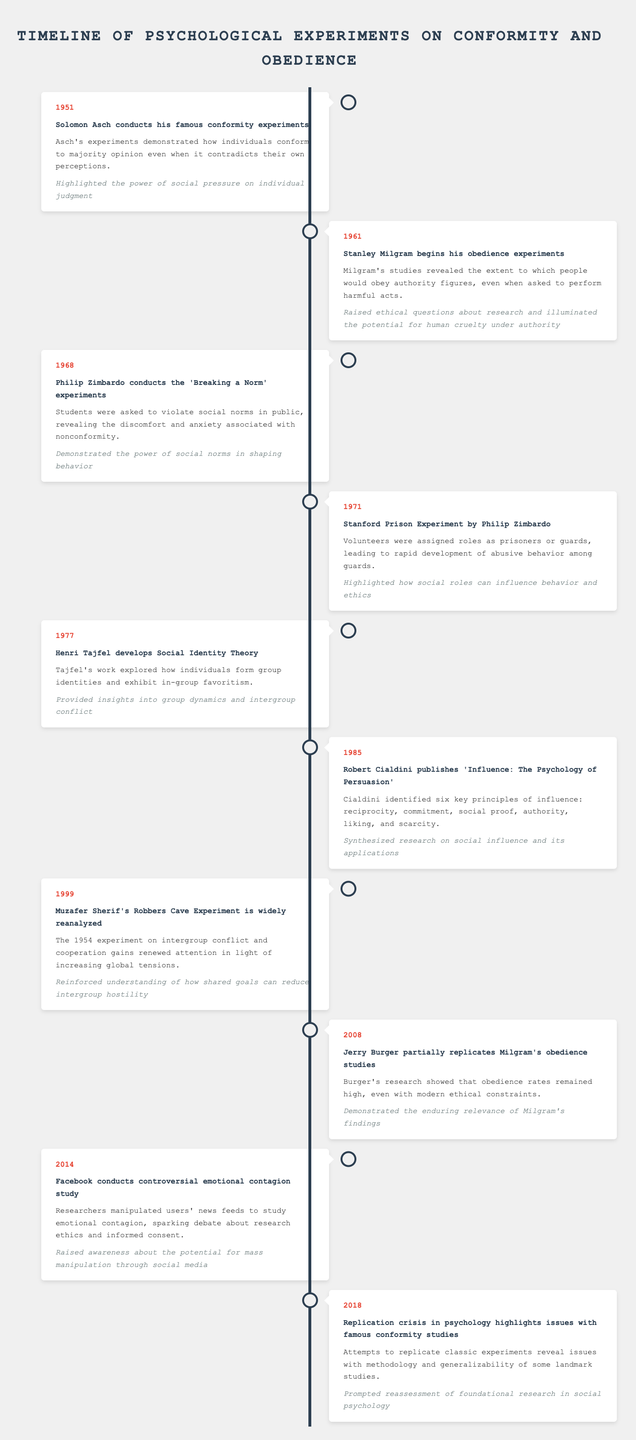What year did Solomon Asch conduct his famous conformity experiments? According to the table, Solomon Asch conducted his famous conformity experiments in the year 1951, as explicitly stated in the data provided.
Answer: 1951 What significant effect did Solomon Asch's experiments highlight? The table states that Asch's experiments highlighted the power of social pressure on individual judgment, which illustrates the impact of group dynamics on personal beliefs.
Answer: Social pressure on individual judgment Which experiment revealed the extent to which people would obey authority figures? The table indicates that Stanley Milgram's obedience experiments, beginning in 1961, revealed this significant insight about obedience to authority, as outlined in the event description.
Answer: Stanley Milgram's obedience experiments How many years apart were Asch's and Milgram's studies conducted? Asch's experiments were conducted in 1951 and Milgram's in 1961. The difference between these years is 1961 - 1951 = 10 years, indicating they are a decade apart in timing.
Answer: 10 years Was the Stanford Prison Experiment conducted before or after the development of Social Identity Theory by Henri Tajfel? The Stanford Prison Experiment occurred in 1971, while Social Identity Theory was developed in 1977. Since 1971 is before 1977, the answer is that the Stanford Prison Experiment was conducted before the development of Social Identity Theory.
Answer: Before What is the main focus of Philip Zimbardo’s 'Breaking a Norm' experiments conducted in 1968? The 1968 experiments conducted by Zimbardo focused on having students violate social norms in public, revealing the discomfort and anxiety associated with nonconformity, according to the description in the table.
Answer: Violation of social norms What notable outcome did Jerry Burger's partial replication of Milgram’s obedience studies in 2008 demonstrate? The significance of Jerry Burger's 2008 replication, as stated in the data, shows that obedience rates remained high even under modern ethical constraints, suggesting that the findings of Milgram’s original study are still relevant today.
Answer: Obedience rates remained high What was the significance of the emotional contagion study conducted by Facebook in 2014? The table notes that the emotional contagion study raised awareness regarding the potential for mass manipulation through social media due to the manipulation of users' news feeds to study emotional impact.
Answer: Mass manipulation through social media Which experiment highlighted how shared goals can reduce intergroup hostility? As per the table, the Robbers Cave Experiment, reanalyzed in 1999, reinforced the understanding that shared goals can reduce intergroup hostility, emphasizing the importance of cooperation among groups.
Answer: Robbers Cave Experiment 